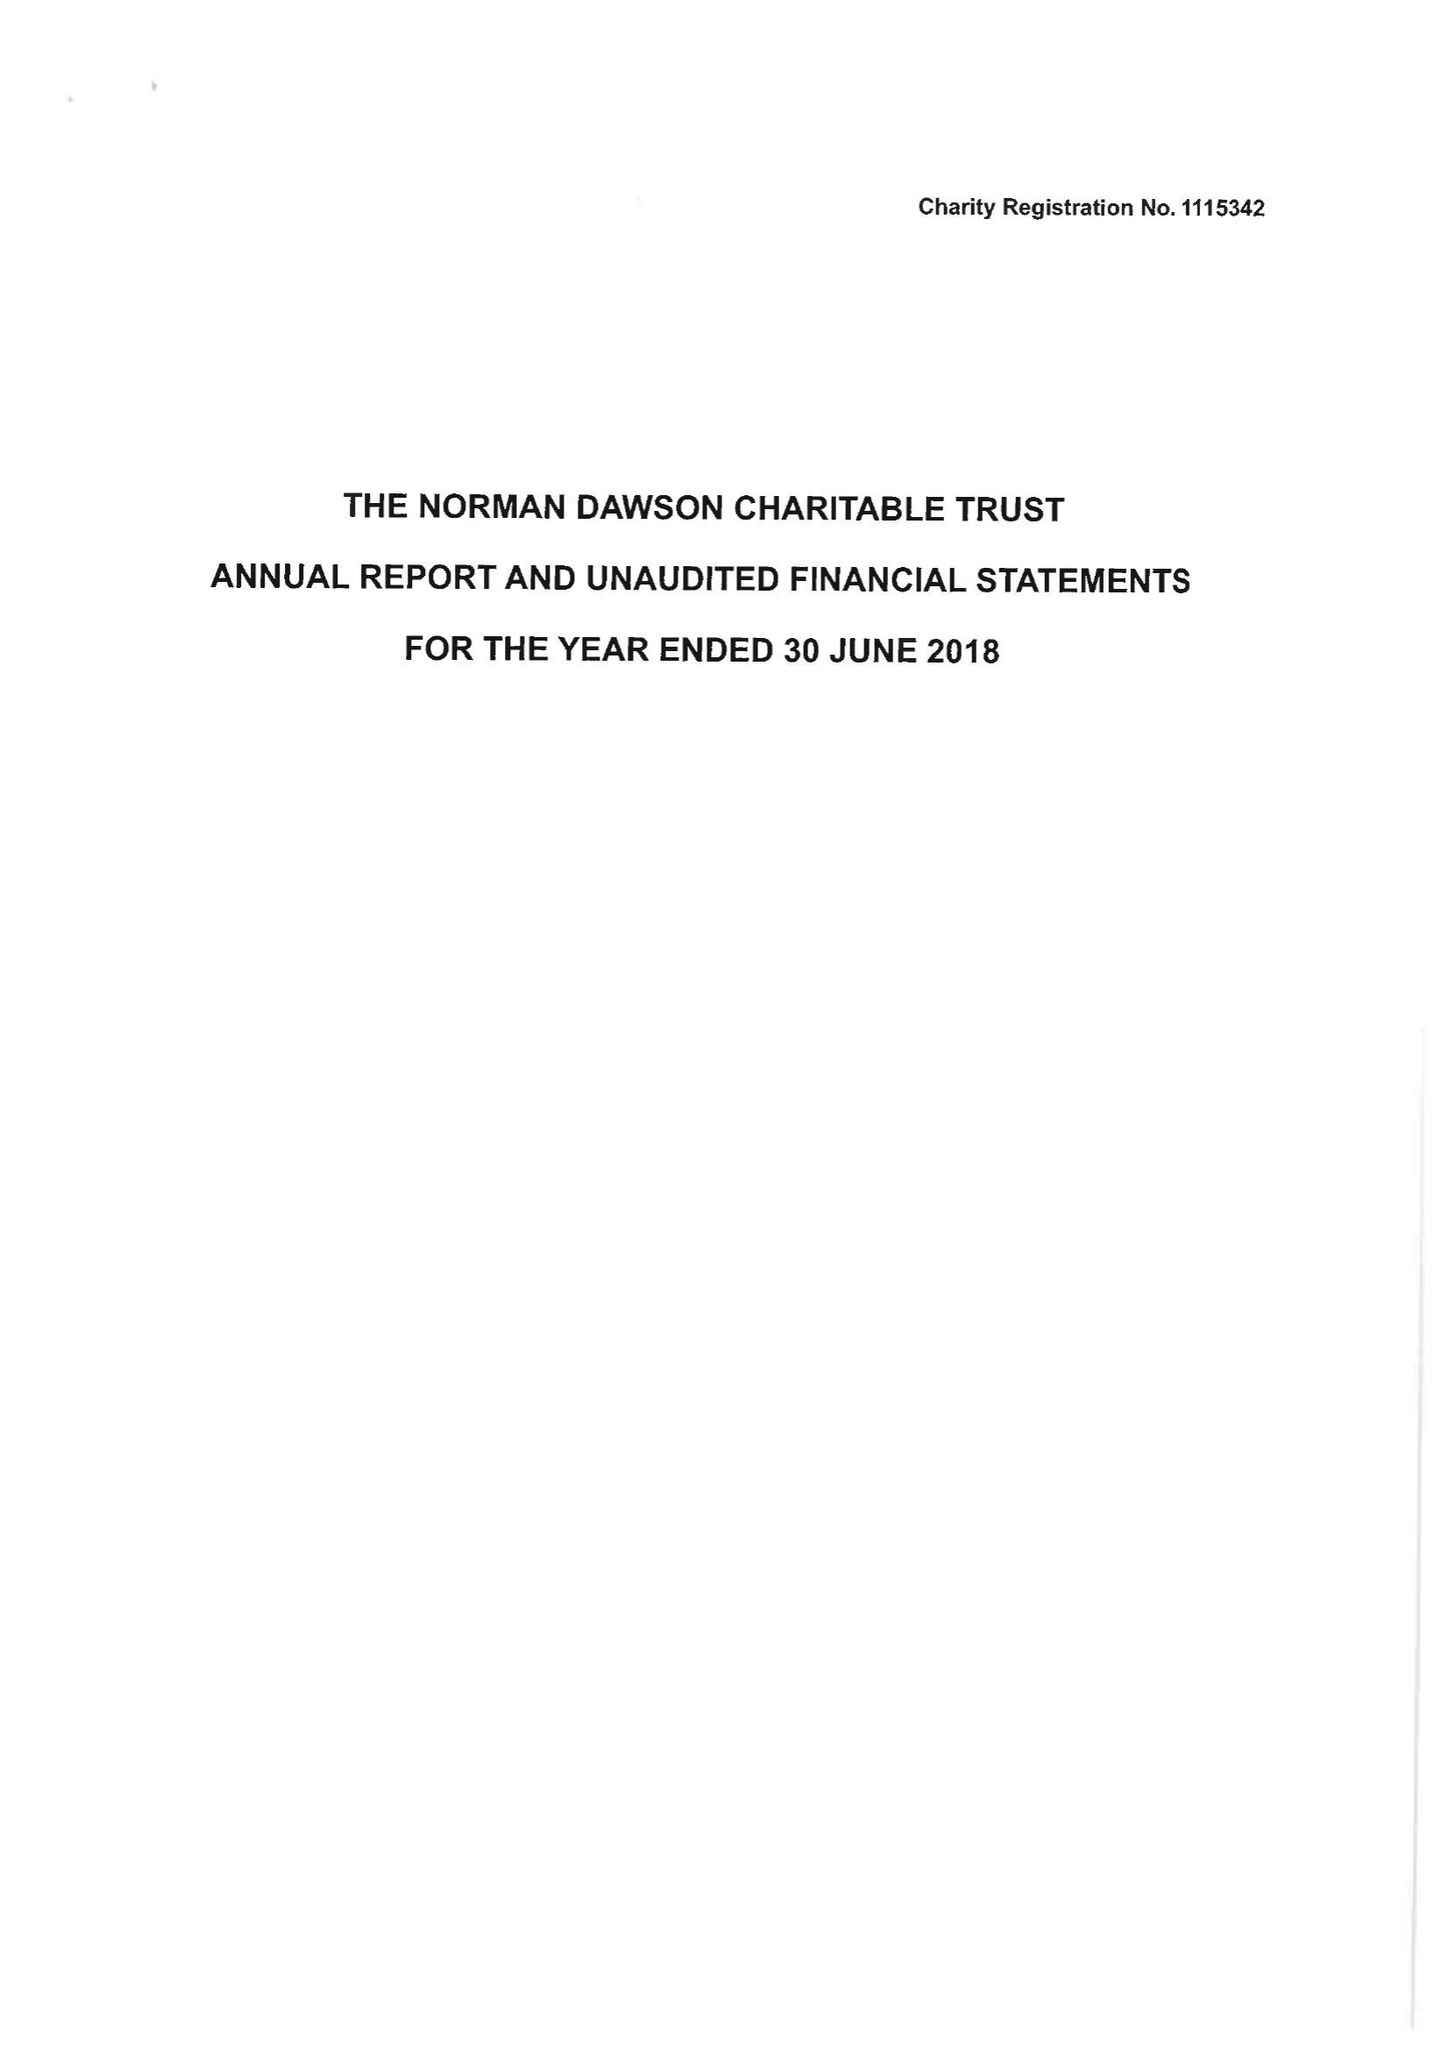What is the value for the report_date?
Answer the question using a single word or phrase. 2018-06-30 